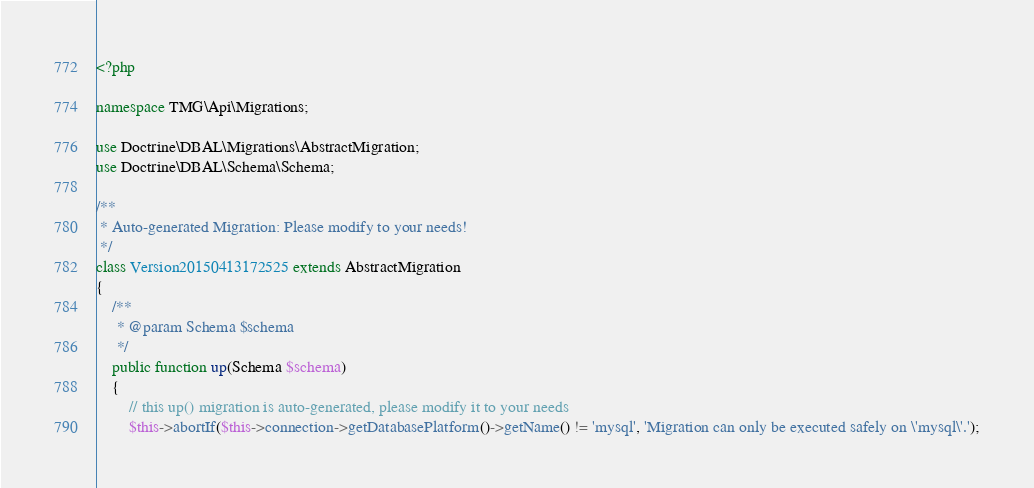<code> <loc_0><loc_0><loc_500><loc_500><_PHP_><?php

namespace TMG\Api\Migrations;

use Doctrine\DBAL\Migrations\AbstractMigration;
use Doctrine\DBAL\Schema\Schema;

/**
 * Auto-generated Migration: Please modify to your needs!
 */
class Version20150413172525 extends AbstractMigration
{
    /**
     * @param Schema $schema
     */
    public function up(Schema $schema)
    {
        // this up() migration is auto-generated, please modify it to your needs
        $this->abortIf($this->connection->getDatabasePlatform()->getName() != 'mysql', 'Migration can only be executed safely on \'mysql\'.');
</code> 